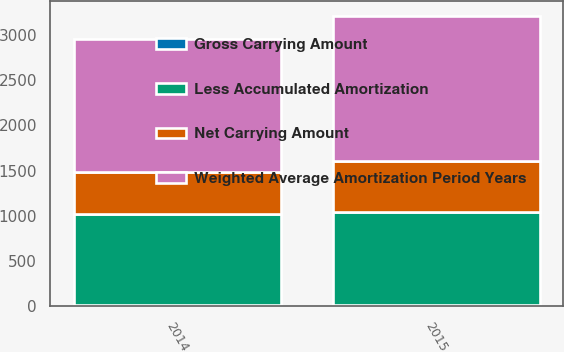Convert chart to OTSL. <chart><loc_0><loc_0><loc_500><loc_500><stacked_bar_chart><ecel><fcel>2015<fcel>2014<nl><fcel>Gross Carrying Amount<fcel>13<fcel>13<nl><fcel>Weighted Average Amortization Period Years<fcel>1597<fcel>1468<nl><fcel>Net Carrying Amount<fcel>563<fcel>466<nl><fcel>Less Accumulated Amortization<fcel>1034<fcel>1002<nl></chart> 